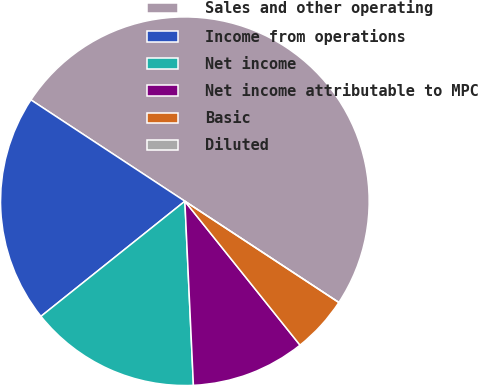Convert chart. <chart><loc_0><loc_0><loc_500><loc_500><pie_chart><fcel>Sales and other operating<fcel>Income from operations<fcel>Net income<fcel>Net income attributable to MPC<fcel>Basic<fcel>Diluted<nl><fcel>49.99%<fcel>20.0%<fcel>15.0%<fcel>10.0%<fcel>5.0%<fcel>0.0%<nl></chart> 